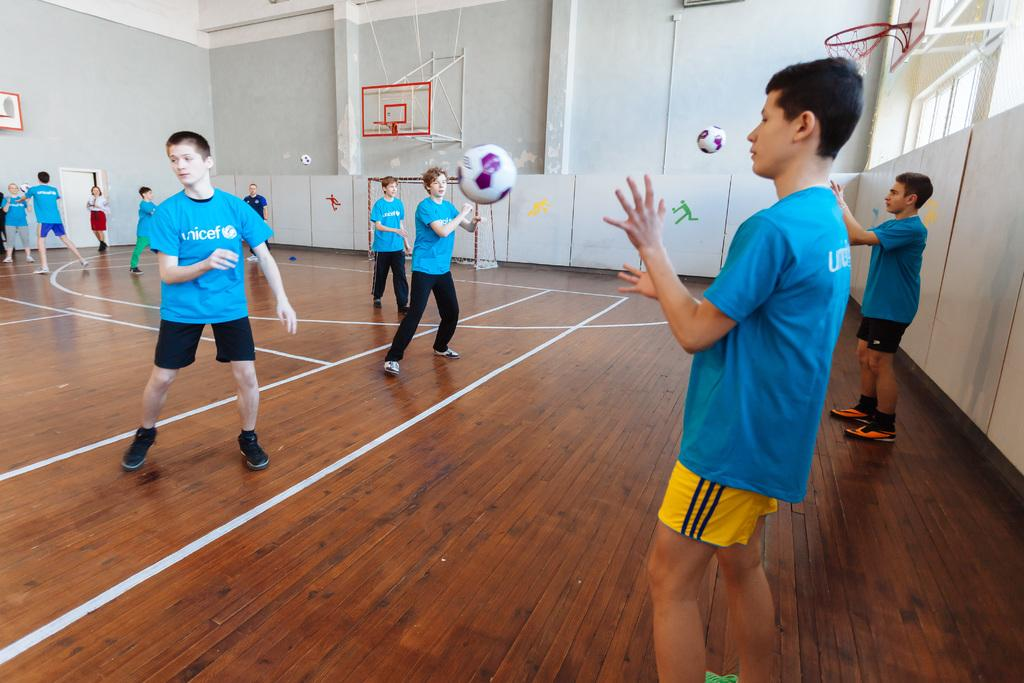What are the people in the image doing? The people in the image are playing. What type of activity are they engaged in? They are playing a game that involves two basketball nets. What type of eggnog is being served to the players in the image? There is no eggnog present in the image; it features people playing a game with basketball nets. How many tomatoes are visible on the court in the image? There are no tomatoes visible in the image; it features people playing a game with basketball nets. 